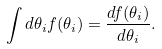Convert formula to latex. <formula><loc_0><loc_0><loc_500><loc_500>\int d \theta _ { i } f ( \theta _ { i } ) = \frac { d f ( \theta _ { i } ) } { d \theta _ { i } } .</formula> 